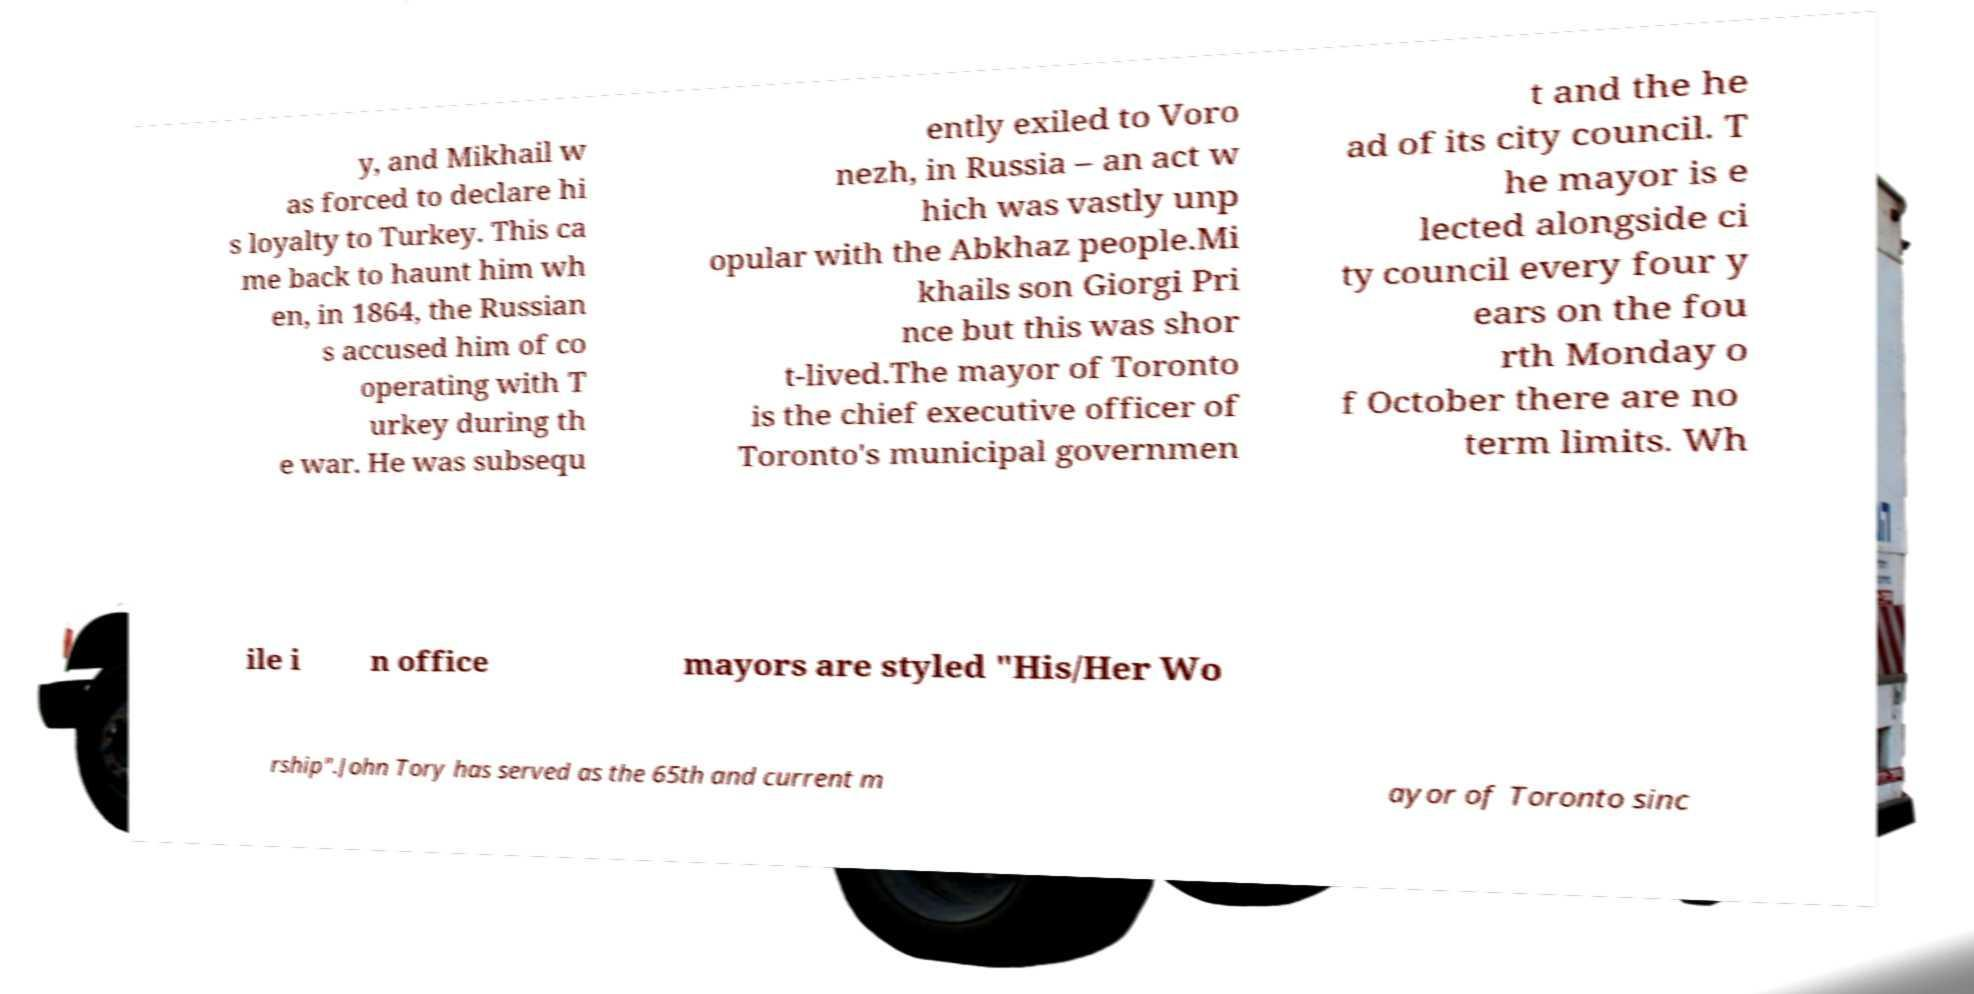What messages or text are displayed in this image? I need them in a readable, typed format. y, and Mikhail w as forced to declare hi s loyalty to Turkey. This ca me back to haunt him wh en, in 1864, the Russian s accused him of co operating with T urkey during th e war. He was subsequ ently exiled to Voro nezh, in Russia – an act w hich was vastly unp opular with the Abkhaz people.Mi khails son Giorgi Pri nce but this was shor t-lived.The mayor of Toronto is the chief executive officer of Toronto's municipal governmen t and the he ad of its city council. T he mayor is e lected alongside ci ty council every four y ears on the fou rth Monday o f October there are no term limits. Wh ile i n office mayors are styled "His/Her Wo rship".John Tory has served as the 65th and current m ayor of Toronto sinc 